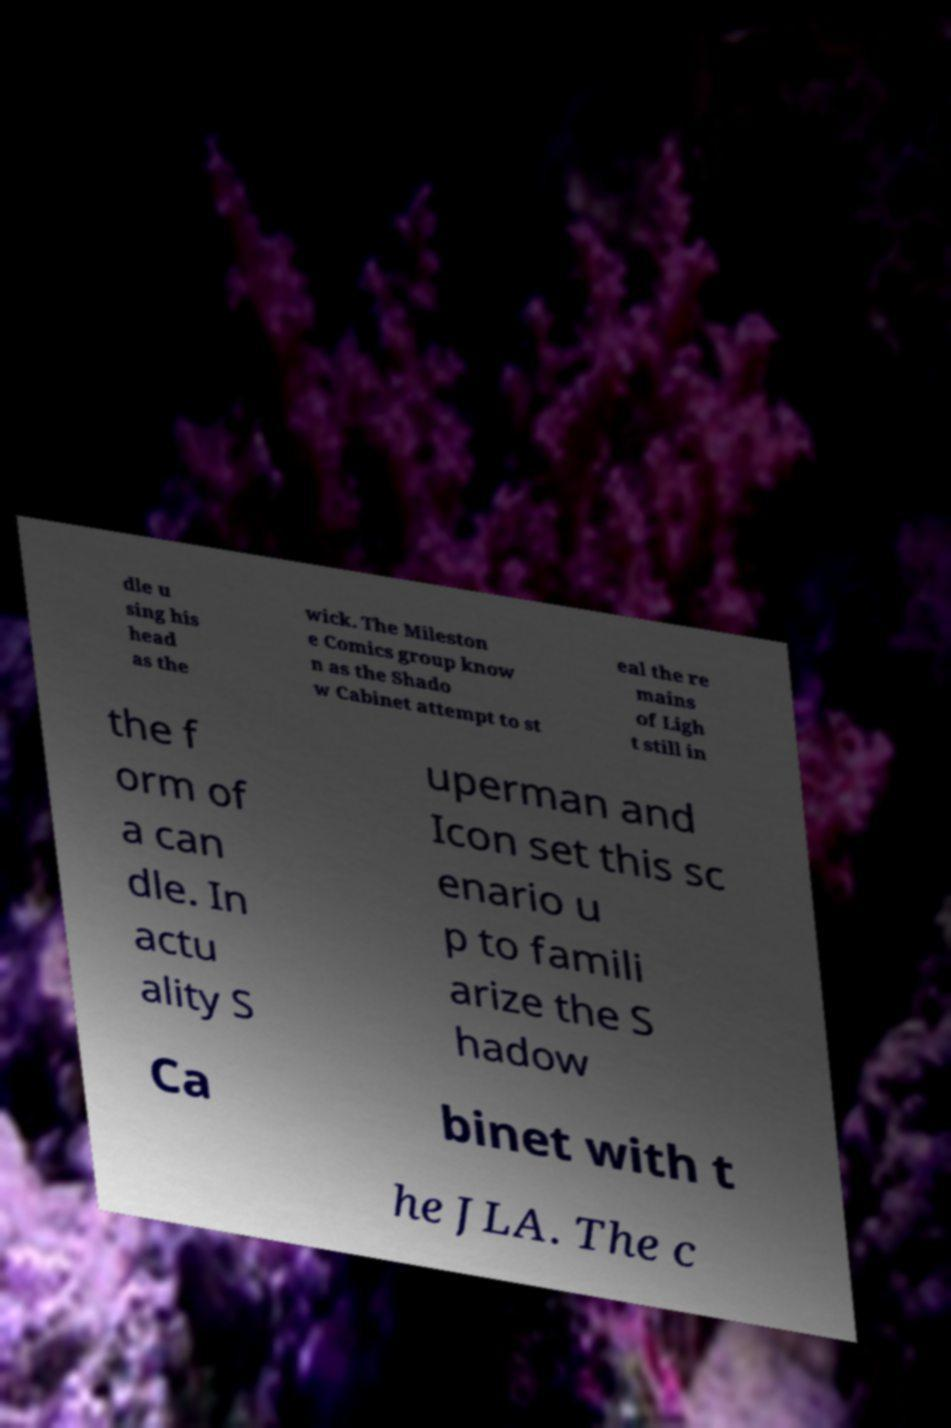Can you read and provide the text displayed in the image?This photo seems to have some interesting text. Can you extract and type it out for me? dle u sing his head as the wick. The Mileston e Comics group know n as the Shado w Cabinet attempt to st eal the re mains of Ligh t still in the f orm of a can dle. In actu ality S uperman and Icon set this sc enario u p to famili arize the S hadow Ca binet with t he JLA. The c 